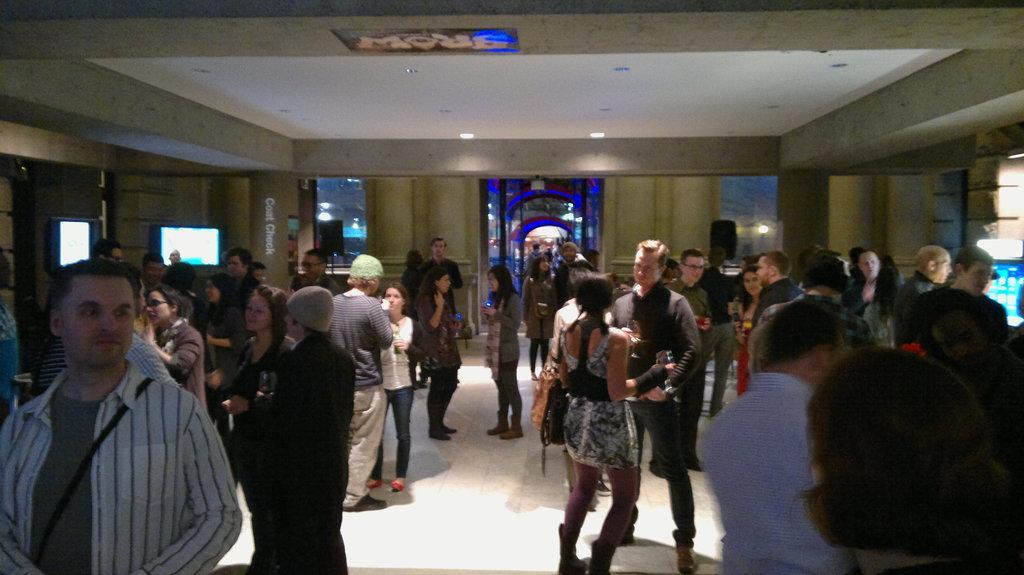Could you give a brief overview of what you see in this image? In this image there are people standing in a hall, around the hall there are walls and glasses on top there is ceiling and lights. 